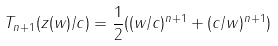<formula> <loc_0><loc_0><loc_500><loc_500>T _ { n + 1 } ( z ( w ) / c ) = \frac { 1 } { 2 } ( ( w / c ) ^ { n + 1 } + ( c / w ) ^ { n + 1 } )</formula> 